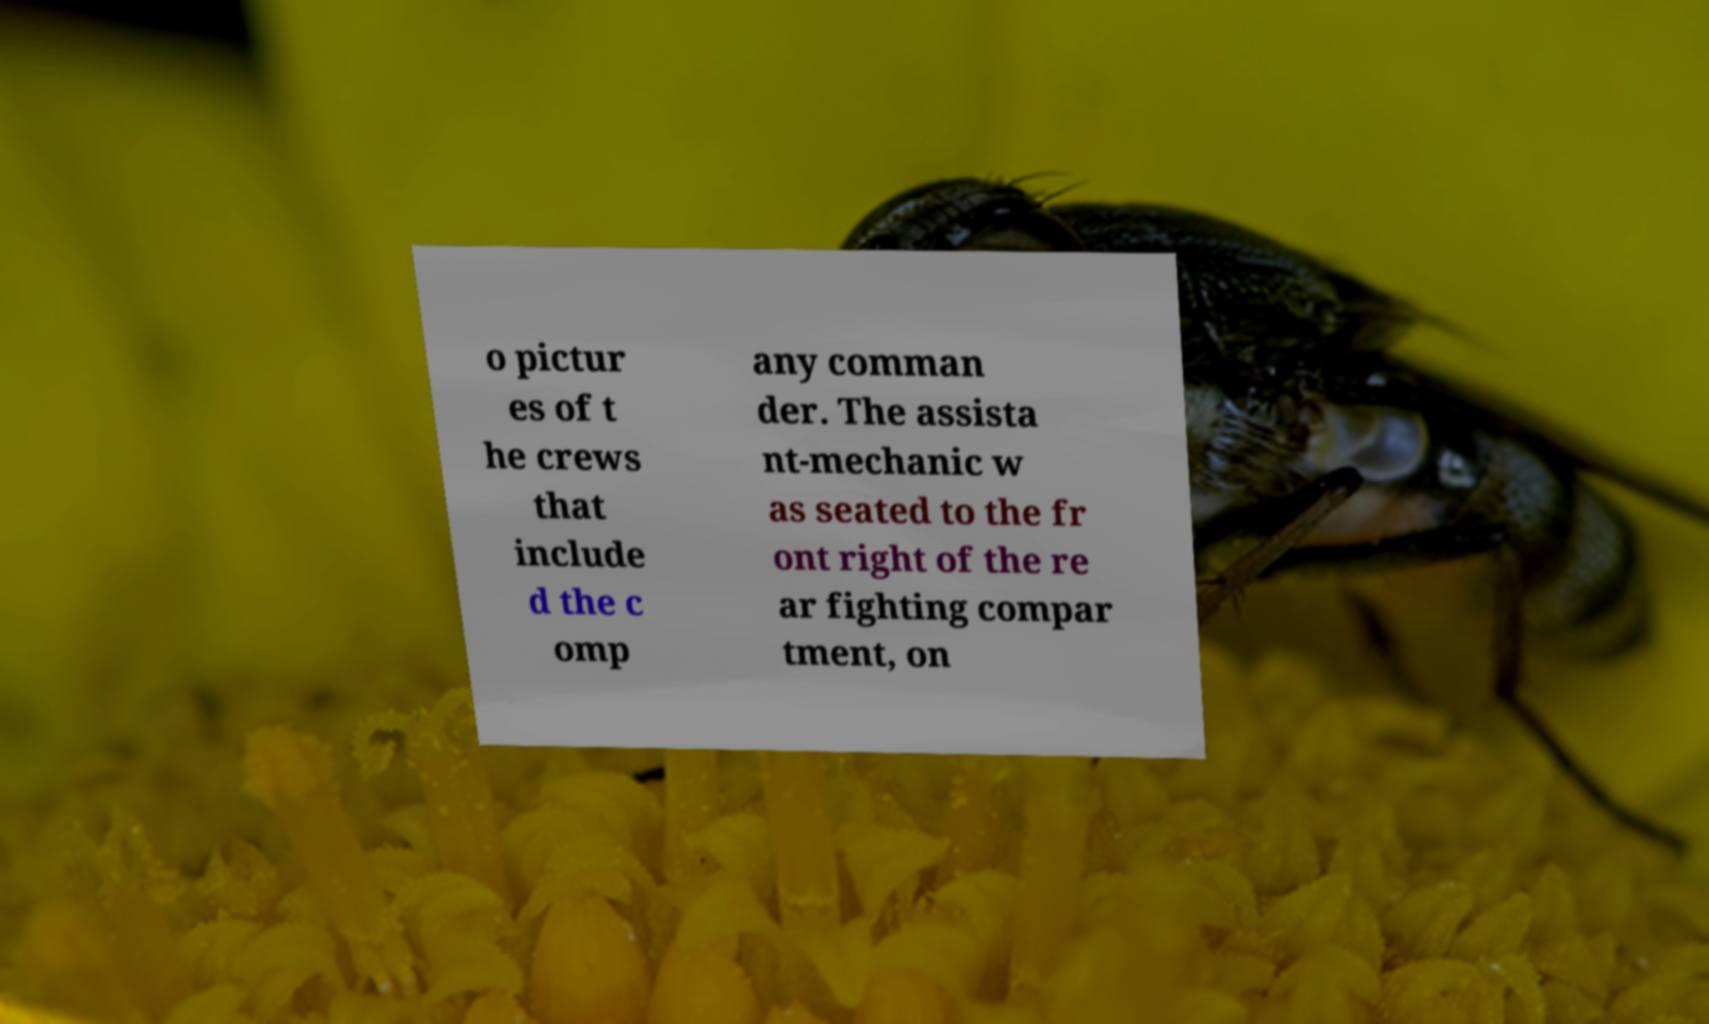Can you read and provide the text displayed in the image?This photo seems to have some interesting text. Can you extract and type it out for me? o pictur es of t he crews that include d the c omp any comman der. The assista nt-mechanic w as seated to the fr ont right of the re ar fighting compar tment, on 